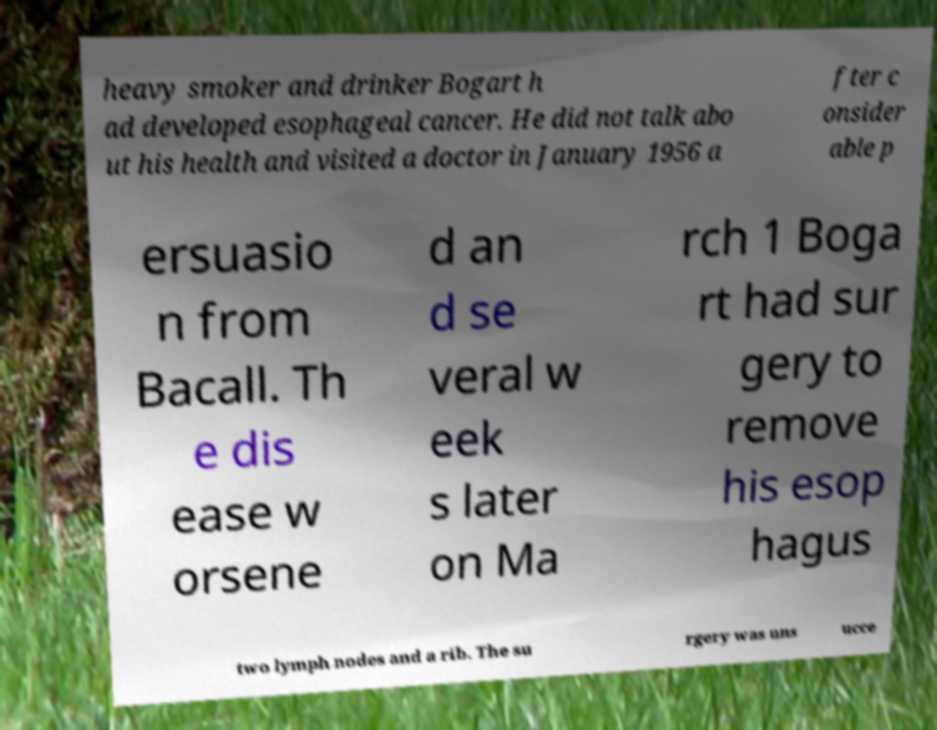Can you read and provide the text displayed in the image?This photo seems to have some interesting text. Can you extract and type it out for me? heavy smoker and drinker Bogart h ad developed esophageal cancer. He did not talk abo ut his health and visited a doctor in January 1956 a fter c onsider able p ersuasio n from Bacall. Th e dis ease w orsene d an d se veral w eek s later on Ma rch 1 Boga rt had sur gery to remove his esop hagus two lymph nodes and a rib. The su rgery was uns ucce 